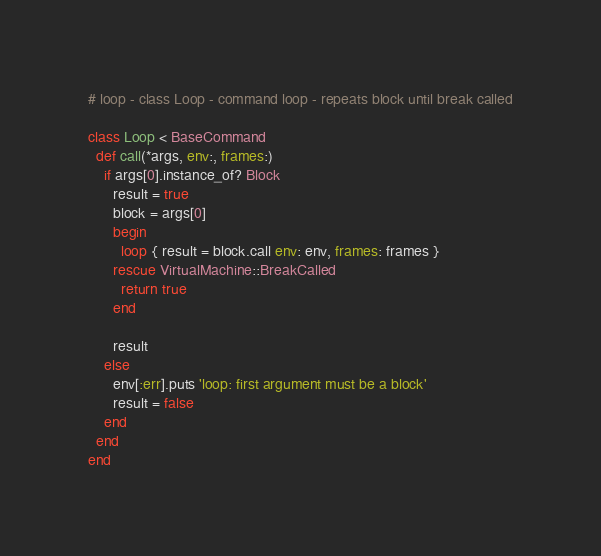<code> <loc_0><loc_0><loc_500><loc_500><_Ruby_># loop - class Loop - command loop - repeats block until break called

class Loop < BaseCommand
  def call(*args, env:, frames:)
    if args[0].instance_of? Block
      result = true
      block = args[0]
      begin
        loop { result = block.call env: env, frames: frames }
      rescue VirtualMachine::BreakCalled
        return true
      end

      result
    else
      env[:err].puts 'loop: first argument must be a block'
      result = false
    end
  end
end
</code> 